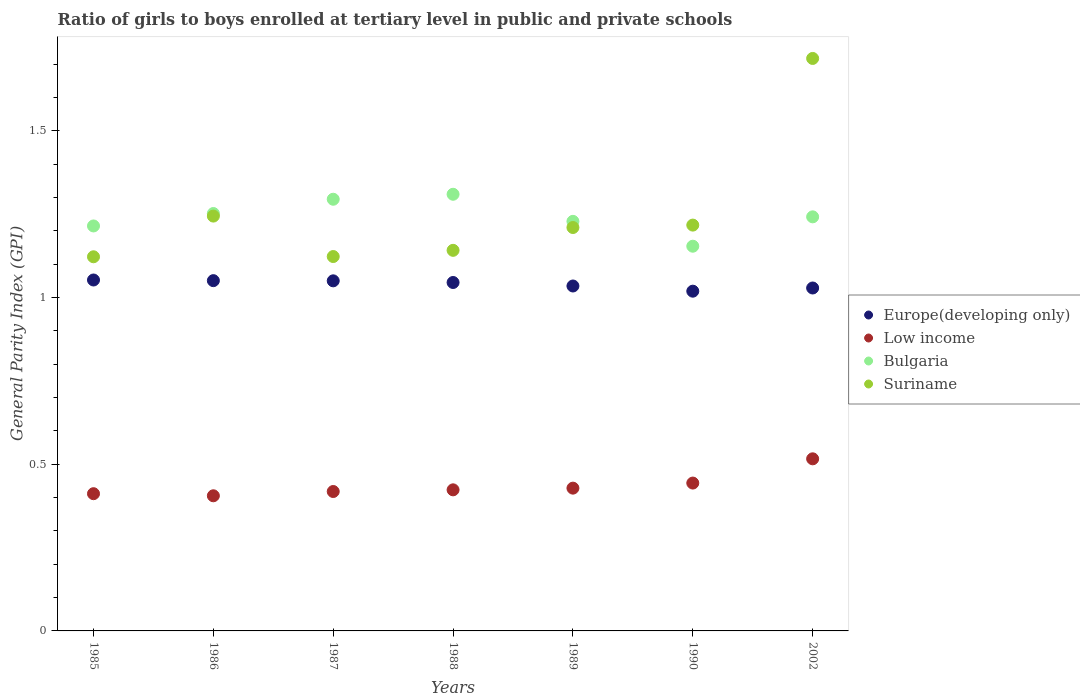Is the number of dotlines equal to the number of legend labels?
Offer a terse response. Yes. What is the general parity index in Europe(developing only) in 1985?
Your answer should be compact. 1.05. Across all years, what is the maximum general parity index in Suriname?
Your response must be concise. 1.72. Across all years, what is the minimum general parity index in Suriname?
Provide a succinct answer. 1.12. In which year was the general parity index in Bulgaria maximum?
Make the answer very short. 1988. What is the total general parity index in Low income in the graph?
Make the answer very short. 3.05. What is the difference between the general parity index in Bulgaria in 1985 and that in 1986?
Keep it short and to the point. -0.04. What is the difference between the general parity index in Bulgaria in 1988 and the general parity index in Europe(developing only) in 1987?
Offer a very short reply. 0.26. What is the average general parity index in Bulgaria per year?
Provide a short and direct response. 1.24. In the year 1990, what is the difference between the general parity index in Low income and general parity index in Suriname?
Keep it short and to the point. -0.77. What is the ratio of the general parity index in Suriname in 1985 to that in 1990?
Give a very brief answer. 0.92. Is the difference between the general parity index in Low income in 1987 and 1988 greater than the difference between the general parity index in Suriname in 1987 and 1988?
Offer a terse response. Yes. What is the difference between the highest and the second highest general parity index in Low income?
Make the answer very short. 0.07. What is the difference between the highest and the lowest general parity index in Low income?
Ensure brevity in your answer.  0.11. In how many years, is the general parity index in Suriname greater than the average general parity index in Suriname taken over all years?
Offer a very short reply. 1. Is it the case that in every year, the sum of the general parity index in Suriname and general parity index in Low income  is greater than the general parity index in Bulgaria?
Provide a succinct answer. Yes. Is the general parity index in Europe(developing only) strictly greater than the general parity index in Suriname over the years?
Make the answer very short. No. Is the general parity index in Europe(developing only) strictly less than the general parity index in Bulgaria over the years?
Your response must be concise. Yes. How many dotlines are there?
Provide a succinct answer. 4. How many years are there in the graph?
Provide a short and direct response. 7. What is the difference between two consecutive major ticks on the Y-axis?
Your answer should be compact. 0.5. Where does the legend appear in the graph?
Your answer should be compact. Center right. How are the legend labels stacked?
Make the answer very short. Vertical. What is the title of the graph?
Offer a terse response. Ratio of girls to boys enrolled at tertiary level in public and private schools. What is the label or title of the Y-axis?
Offer a very short reply. General Parity Index (GPI). What is the General Parity Index (GPI) of Europe(developing only) in 1985?
Provide a short and direct response. 1.05. What is the General Parity Index (GPI) of Low income in 1985?
Make the answer very short. 0.41. What is the General Parity Index (GPI) of Bulgaria in 1985?
Your response must be concise. 1.21. What is the General Parity Index (GPI) in Suriname in 1985?
Provide a succinct answer. 1.12. What is the General Parity Index (GPI) in Europe(developing only) in 1986?
Keep it short and to the point. 1.05. What is the General Parity Index (GPI) in Low income in 1986?
Give a very brief answer. 0.41. What is the General Parity Index (GPI) in Bulgaria in 1986?
Your answer should be compact. 1.25. What is the General Parity Index (GPI) of Suriname in 1986?
Keep it short and to the point. 1.24. What is the General Parity Index (GPI) of Europe(developing only) in 1987?
Your answer should be very brief. 1.05. What is the General Parity Index (GPI) of Low income in 1987?
Your answer should be compact. 0.42. What is the General Parity Index (GPI) of Bulgaria in 1987?
Offer a terse response. 1.29. What is the General Parity Index (GPI) in Suriname in 1987?
Offer a very short reply. 1.12. What is the General Parity Index (GPI) of Europe(developing only) in 1988?
Give a very brief answer. 1.05. What is the General Parity Index (GPI) in Low income in 1988?
Provide a succinct answer. 0.42. What is the General Parity Index (GPI) in Bulgaria in 1988?
Offer a very short reply. 1.31. What is the General Parity Index (GPI) of Suriname in 1988?
Ensure brevity in your answer.  1.14. What is the General Parity Index (GPI) of Europe(developing only) in 1989?
Your answer should be very brief. 1.03. What is the General Parity Index (GPI) of Low income in 1989?
Make the answer very short. 0.43. What is the General Parity Index (GPI) in Bulgaria in 1989?
Make the answer very short. 1.23. What is the General Parity Index (GPI) in Suriname in 1989?
Provide a short and direct response. 1.21. What is the General Parity Index (GPI) of Europe(developing only) in 1990?
Your response must be concise. 1.02. What is the General Parity Index (GPI) in Low income in 1990?
Provide a short and direct response. 0.44. What is the General Parity Index (GPI) of Bulgaria in 1990?
Your response must be concise. 1.15. What is the General Parity Index (GPI) in Suriname in 1990?
Your response must be concise. 1.22. What is the General Parity Index (GPI) of Europe(developing only) in 2002?
Offer a very short reply. 1.03. What is the General Parity Index (GPI) in Low income in 2002?
Provide a succinct answer. 0.52. What is the General Parity Index (GPI) in Bulgaria in 2002?
Provide a short and direct response. 1.24. What is the General Parity Index (GPI) in Suriname in 2002?
Your response must be concise. 1.72. Across all years, what is the maximum General Parity Index (GPI) in Europe(developing only)?
Offer a very short reply. 1.05. Across all years, what is the maximum General Parity Index (GPI) of Low income?
Offer a terse response. 0.52. Across all years, what is the maximum General Parity Index (GPI) in Bulgaria?
Your answer should be very brief. 1.31. Across all years, what is the maximum General Parity Index (GPI) in Suriname?
Ensure brevity in your answer.  1.72. Across all years, what is the minimum General Parity Index (GPI) in Europe(developing only)?
Provide a short and direct response. 1.02. Across all years, what is the minimum General Parity Index (GPI) in Low income?
Your response must be concise. 0.41. Across all years, what is the minimum General Parity Index (GPI) of Bulgaria?
Offer a terse response. 1.15. Across all years, what is the minimum General Parity Index (GPI) in Suriname?
Provide a short and direct response. 1.12. What is the total General Parity Index (GPI) in Europe(developing only) in the graph?
Make the answer very short. 7.28. What is the total General Parity Index (GPI) in Low income in the graph?
Keep it short and to the point. 3.05. What is the total General Parity Index (GPI) of Bulgaria in the graph?
Give a very brief answer. 8.7. What is the total General Parity Index (GPI) in Suriname in the graph?
Offer a very short reply. 8.78. What is the difference between the General Parity Index (GPI) of Europe(developing only) in 1985 and that in 1986?
Your response must be concise. 0. What is the difference between the General Parity Index (GPI) of Low income in 1985 and that in 1986?
Ensure brevity in your answer.  0.01. What is the difference between the General Parity Index (GPI) in Bulgaria in 1985 and that in 1986?
Offer a very short reply. -0.04. What is the difference between the General Parity Index (GPI) of Suriname in 1985 and that in 1986?
Give a very brief answer. -0.12. What is the difference between the General Parity Index (GPI) in Europe(developing only) in 1985 and that in 1987?
Offer a terse response. 0. What is the difference between the General Parity Index (GPI) in Low income in 1985 and that in 1987?
Offer a very short reply. -0.01. What is the difference between the General Parity Index (GPI) of Bulgaria in 1985 and that in 1987?
Provide a short and direct response. -0.08. What is the difference between the General Parity Index (GPI) in Suriname in 1985 and that in 1987?
Offer a very short reply. -0. What is the difference between the General Parity Index (GPI) of Europe(developing only) in 1985 and that in 1988?
Provide a succinct answer. 0.01. What is the difference between the General Parity Index (GPI) of Low income in 1985 and that in 1988?
Ensure brevity in your answer.  -0.01. What is the difference between the General Parity Index (GPI) of Bulgaria in 1985 and that in 1988?
Give a very brief answer. -0.1. What is the difference between the General Parity Index (GPI) in Suriname in 1985 and that in 1988?
Offer a very short reply. -0.02. What is the difference between the General Parity Index (GPI) in Europe(developing only) in 1985 and that in 1989?
Your answer should be very brief. 0.02. What is the difference between the General Parity Index (GPI) of Low income in 1985 and that in 1989?
Provide a short and direct response. -0.02. What is the difference between the General Parity Index (GPI) in Bulgaria in 1985 and that in 1989?
Your response must be concise. -0.01. What is the difference between the General Parity Index (GPI) of Suriname in 1985 and that in 1989?
Provide a short and direct response. -0.09. What is the difference between the General Parity Index (GPI) in Europe(developing only) in 1985 and that in 1990?
Ensure brevity in your answer.  0.03. What is the difference between the General Parity Index (GPI) in Low income in 1985 and that in 1990?
Your answer should be very brief. -0.03. What is the difference between the General Parity Index (GPI) of Bulgaria in 1985 and that in 1990?
Provide a succinct answer. 0.06. What is the difference between the General Parity Index (GPI) of Suriname in 1985 and that in 1990?
Give a very brief answer. -0.1. What is the difference between the General Parity Index (GPI) of Europe(developing only) in 1985 and that in 2002?
Provide a succinct answer. 0.02. What is the difference between the General Parity Index (GPI) in Low income in 1985 and that in 2002?
Keep it short and to the point. -0.1. What is the difference between the General Parity Index (GPI) of Bulgaria in 1985 and that in 2002?
Your answer should be very brief. -0.03. What is the difference between the General Parity Index (GPI) in Suriname in 1985 and that in 2002?
Your response must be concise. -0.59. What is the difference between the General Parity Index (GPI) of Europe(developing only) in 1986 and that in 1987?
Make the answer very short. 0. What is the difference between the General Parity Index (GPI) of Low income in 1986 and that in 1987?
Your answer should be very brief. -0.01. What is the difference between the General Parity Index (GPI) in Bulgaria in 1986 and that in 1987?
Keep it short and to the point. -0.04. What is the difference between the General Parity Index (GPI) in Suriname in 1986 and that in 1987?
Keep it short and to the point. 0.12. What is the difference between the General Parity Index (GPI) in Europe(developing only) in 1986 and that in 1988?
Give a very brief answer. 0.01. What is the difference between the General Parity Index (GPI) in Low income in 1986 and that in 1988?
Offer a very short reply. -0.02. What is the difference between the General Parity Index (GPI) in Bulgaria in 1986 and that in 1988?
Keep it short and to the point. -0.06. What is the difference between the General Parity Index (GPI) of Suriname in 1986 and that in 1988?
Provide a succinct answer. 0.1. What is the difference between the General Parity Index (GPI) of Europe(developing only) in 1986 and that in 1989?
Your answer should be very brief. 0.02. What is the difference between the General Parity Index (GPI) in Low income in 1986 and that in 1989?
Your answer should be very brief. -0.02. What is the difference between the General Parity Index (GPI) of Bulgaria in 1986 and that in 1989?
Ensure brevity in your answer.  0.02. What is the difference between the General Parity Index (GPI) of Suriname in 1986 and that in 1989?
Offer a terse response. 0.03. What is the difference between the General Parity Index (GPI) of Europe(developing only) in 1986 and that in 1990?
Your answer should be compact. 0.03. What is the difference between the General Parity Index (GPI) in Low income in 1986 and that in 1990?
Provide a succinct answer. -0.04. What is the difference between the General Parity Index (GPI) in Bulgaria in 1986 and that in 1990?
Your answer should be compact. 0.1. What is the difference between the General Parity Index (GPI) in Suriname in 1986 and that in 1990?
Give a very brief answer. 0.03. What is the difference between the General Parity Index (GPI) of Europe(developing only) in 1986 and that in 2002?
Your answer should be compact. 0.02. What is the difference between the General Parity Index (GPI) of Low income in 1986 and that in 2002?
Offer a very short reply. -0.11. What is the difference between the General Parity Index (GPI) in Bulgaria in 1986 and that in 2002?
Make the answer very short. 0.01. What is the difference between the General Parity Index (GPI) in Suriname in 1986 and that in 2002?
Offer a very short reply. -0.47. What is the difference between the General Parity Index (GPI) of Europe(developing only) in 1987 and that in 1988?
Make the answer very short. 0.01. What is the difference between the General Parity Index (GPI) of Low income in 1987 and that in 1988?
Offer a very short reply. -0.01. What is the difference between the General Parity Index (GPI) in Bulgaria in 1987 and that in 1988?
Provide a short and direct response. -0.01. What is the difference between the General Parity Index (GPI) in Suriname in 1987 and that in 1988?
Offer a very short reply. -0.02. What is the difference between the General Parity Index (GPI) in Europe(developing only) in 1987 and that in 1989?
Offer a terse response. 0.02. What is the difference between the General Parity Index (GPI) in Low income in 1987 and that in 1989?
Keep it short and to the point. -0.01. What is the difference between the General Parity Index (GPI) of Bulgaria in 1987 and that in 1989?
Give a very brief answer. 0.07. What is the difference between the General Parity Index (GPI) in Suriname in 1987 and that in 1989?
Keep it short and to the point. -0.09. What is the difference between the General Parity Index (GPI) in Europe(developing only) in 1987 and that in 1990?
Offer a terse response. 0.03. What is the difference between the General Parity Index (GPI) in Low income in 1987 and that in 1990?
Make the answer very short. -0.03. What is the difference between the General Parity Index (GPI) of Bulgaria in 1987 and that in 1990?
Make the answer very short. 0.14. What is the difference between the General Parity Index (GPI) of Suriname in 1987 and that in 1990?
Provide a succinct answer. -0.09. What is the difference between the General Parity Index (GPI) in Europe(developing only) in 1987 and that in 2002?
Provide a short and direct response. 0.02. What is the difference between the General Parity Index (GPI) of Low income in 1987 and that in 2002?
Give a very brief answer. -0.1. What is the difference between the General Parity Index (GPI) of Bulgaria in 1987 and that in 2002?
Ensure brevity in your answer.  0.05. What is the difference between the General Parity Index (GPI) in Suriname in 1987 and that in 2002?
Your response must be concise. -0.59. What is the difference between the General Parity Index (GPI) in Europe(developing only) in 1988 and that in 1989?
Make the answer very short. 0.01. What is the difference between the General Parity Index (GPI) in Low income in 1988 and that in 1989?
Give a very brief answer. -0.01. What is the difference between the General Parity Index (GPI) of Bulgaria in 1988 and that in 1989?
Ensure brevity in your answer.  0.08. What is the difference between the General Parity Index (GPI) of Suriname in 1988 and that in 1989?
Offer a very short reply. -0.07. What is the difference between the General Parity Index (GPI) of Europe(developing only) in 1988 and that in 1990?
Offer a terse response. 0.03. What is the difference between the General Parity Index (GPI) of Low income in 1988 and that in 1990?
Provide a short and direct response. -0.02. What is the difference between the General Parity Index (GPI) in Bulgaria in 1988 and that in 1990?
Provide a short and direct response. 0.16. What is the difference between the General Parity Index (GPI) of Suriname in 1988 and that in 1990?
Offer a terse response. -0.08. What is the difference between the General Parity Index (GPI) of Europe(developing only) in 1988 and that in 2002?
Your answer should be very brief. 0.02. What is the difference between the General Parity Index (GPI) in Low income in 1988 and that in 2002?
Your answer should be compact. -0.09. What is the difference between the General Parity Index (GPI) in Bulgaria in 1988 and that in 2002?
Provide a short and direct response. 0.07. What is the difference between the General Parity Index (GPI) of Suriname in 1988 and that in 2002?
Keep it short and to the point. -0.58. What is the difference between the General Parity Index (GPI) of Europe(developing only) in 1989 and that in 1990?
Ensure brevity in your answer.  0.02. What is the difference between the General Parity Index (GPI) in Low income in 1989 and that in 1990?
Ensure brevity in your answer.  -0.02. What is the difference between the General Parity Index (GPI) of Bulgaria in 1989 and that in 1990?
Keep it short and to the point. 0.07. What is the difference between the General Parity Index (GPI) in Suriname in 1989 and that in 1990?
Offer a very short reply. -0.01. What is the difference between the General Parity Index (GPI) of Europe(developing only) in 1989 and that in 2002?
Your response must be concise. 0.01. What is the difference between the General Parity Index (GPI) of Low income in 1989 and that in 2002?
Provide a succinct answer. -0.09. What is the difference between the General Parity Index (GPI) in Bulgaria in 1989 and that in 2002?
Keep it short and to the point. -0.01. What is the difference between the General Parity Index (GPI) of Suriname in 1989 and that in 2002?
Keep it short and to the point. -0.51. What is the difference between the General Parity Index (GPI) of Europe(developing only) in 1990 and that in 2002?
Offer a terse response. -0.01. What is the difference between the General Parity Index (GPI) of Low income in 1990 and that in 2002?
Make the answer very short. -0.07. What is the difference between the General Parity Index (GPI) in Bulgaria in 1990 and that in 2002?
Your answer should be very brief. -0.09. What is the difference between the General Parity Index (GPI) in Suriname in 1990 and that in 2002?
Provide a short and direct response. -0.5. What is the difference between the General Parity Index (GPI) in Europe(developing only) in 1985 and the General Parity Index (GPI) in Low income in 1986?
Make the answer very short. 0.65. What is the difference between the General Parity Index (GPI) of Europe(developing only) in 1985 and the General Parity Index (GPI) of Bulgaria in 1986?
Offer a very short reply. -0.2. What is the difference between the General Parity Index (GPI) of Europe(developing only) in 1985 and the General Parity Index (GPI) of Suriname in 1986?
Give a very brief answer. -0.19. What is the difference between the General Parity Index (GPI) of Low income in 1985 and the General Parity Index (GPI) of Bulgaria in 1986?
Give a very brief answer. -0.84. What is the difference between the General Parity Index (GPI) of Low income in 1985 and the General Parity Index (GPI) of Suriname in 1986?
Your answer should be compact. -0.83. What is the difference between the General Parity Index (GPI) in Bulgaria in 1985 and the General Parity Index (GPI) in Suriname in 1986?
Your response must be concise. -0.03. What is the difference between the General Parity Index (GPI) of Europe(developing only) in 1985 and the General Parity Index (GPI) of Low income in 1987?
Make the answer very short. 0.63. What is the difference between the General Parity Index (GPI) of Europe(developing only) in 1985 and the General Parity Index (GPI) of Bulgaria in 1987?
Your answer should be compact. -0.24. What is the difference between the General Parity Index (GPI) of Europe(developing only) in 1985 and the General Parity Index (GPI) of Suriname in 1987?
Give a very brief answer. -0.07. What is the difference between the General Parity Index (GPI) in Low income in 1985 and the General Parity Index (GPI) in Bulgaria in 1987?
Offer a terse response. -0.88. What is the difference between the General Parity Index (GPI) in Low income in 1985 and the General Parity Index (GPI) in Suriname in 1987?
Make the answer very short. -0.71. What is the difference between the General Parity Index (GPI) of Bulgaria in 1985 and the General Parity Index (GPI) of Suriname in 1987?
Your answer should be compact. 0.09. What is the difference between the General Parity Index (GPI) of Europe(developing only) in 1985 and the General Parity Index (GPI) of Low income in 1988?
Your response must be concise. 0.63. What is the difference between the General Parity Index (GPI) in Europe(developing only) in 1985 and the General Parity Index (GPI) in Bulgaria in 1988?
Your answer should be very brief. -0.26. What is the difference between the General Parity Index (GPI) of Europe(developing only) in 1985 and the General Parity Index (GPI) of Suriname in 1988?
Your answer should be compact. -0.09. What is the difference between the General Parity Index (GPI) in Low income in 1985 and the General Parity Index (GPI) in Bulgaria in 1988?
Provide a succinct answer. -0.9. What is the difference between the General Parity Index (GPI) in Low income in 1985 and the General Parity Index (GPI) in Suriname in 1988?
Offer a very short reply. -0.73. What is the difference between the General Parity Index (GPI) in Bulgaria in 1985 and the General Parity Index (GPI) in Suriname in 1988?
Make the answer very short. 0.07. What is the difference between the General Parity Index (GPI) in Europe(developing only) in 1985 and the General Parity Index (GPI) in Low income in 1989?
Offer a terse response. 0.62. What is the difference between the General Parity Index (GPI) of Europe(developing only) in 1985 and the General Parity Index (GPI) of Bulgaria in 1989?
Keep it short and to the point. -0.18. What is the difference between the General Parity Index (GPI) in Europe(developing only) in 1985 and the General Parity Index (GPI) in Suriname in 1989?
Ensure brevity in your answer.  -0.16. What is the difference between the General Parity Index (GPI) of Low income in 1985 and the General Parity Index (GPI) of Bulgaria in 1989?
Offer a very short reply. -0.82. What is the difference between the General Parity Index (GPI) of Low income in 1985 and the General Parity Index (GPI) of Suriname in 1989?
Offer a terse response. -0.8. What is the difference between the General Parity Index (GPI) of Bulgaria in 1985 and the General Parity Index (GPI) of Suriname in 1989?
Keep it short and to the point. 0. What is the difference between the General Parity Index (GPI) in Europe(developing only) in 1985 and the General Parity Index (GPI) in Low income in 1990?
Your answer should be very brief. 0.61. What is the difference between the General Parity Index (GPI) of Europe(developing only) in 1985 and the General Parity Index (GPI) of Bulgaria in 1990?
Ensure brevity in your answer.  -0.1. What is the difference between the General Parity Index (GPI) in Europe(developing only) in 1985 and the General Parity Index (GPI) in Suriname in 1990?
Give a very brief answer. -0.16. What is the difference between the General Parity Index (GPI) in Low income in 1985 and the General Parity Index (GPI) in Bulgaria in 1990?
Make the answer very short. -0.74. What is the difference between the General Parity Index (GPI) of Low income in 1985 and the General Parity Index (GPI) of Suriname in 1990?
Your answer should be compact. -0.81. What is the difference between the General Parity Index (GPI) in Bulgaria in 1985 and the General Parity Index (GPI) in Suriname in 1990?
Provide a succinct answer. -0. What is the difference between the General Parity Index (GPI) of Europe(developing only) in 1985 and the General Parity Index (GPI) of Low income in 2002?
Ensure brevity in your answer.  0.54. What is the difference between the General Parity Index (GPI) in Europe(developing only) in 1985 and the General Parity Index (GPI) in Bulgaria in 2002?
Provide a succinct answer. -0.19. What is the difference between the General Parity Index (GPI) in Europe(developing only) in 1985 and the General Parity Index (GPI) in Suriname in 2002?
Keep it short and to the point. -0.66. What is the difference between the General Parity Index (GPI) of Low income in 1985 and the General Parity Index (GPI) of Bulgaria in 2002?
Provide a short and direct response. -0.83. What is the difference between the General Parity Index (GPI) in Low income in 1985 and the General Parity Index (GPI) in Suriname in 2002?
Offer a very short reply. -1.31. What is the difference between the General Parity Index (GPI) of Bulgaria in 1985 and the General Parity Index (GPI) of Suriname in 2002?
Give a very brief answer. -0.5. What is the difference between the General Parity Index (GPI) in Europe(developing only) in 1986 and the General Parity Index (GPI) in Low income in 1987?
Give a very brief answer. 0.63. What is the difference between the General Parity Index (GPI) in Europe(developing only) in 1986 and the General Parity Index (GPI) in Bulgaria in 1987?
Your answer should be compact. -0.24. What is the difference between the General Parity Index (GPI) in Europe(developing only) in 1986 and the General Parity Index (GPI) in Suriname in 1987?
Your answer should be very brief. -0.07. What is the difference between the General Parity Index (GPI) in Low income in 1986 and the General Parity Index (GPI) in Bulgaria in 1987?
Keep it short and to the point. -0.89. What is the difference between the General Parity Index (GPI) of Low income in 1986 and the General Parity Index (GPI) of Suriname in 1987?
Offer a terse response. -0.72. What is the difference between the General Parity Index (GPI) of Bulgaria in 1986 and the General Parity Index (GPI) of Suriname in 1987?
Offer a very short reply. 0.13. What is the difference between the General Parity Index (GPI) of Europe(developing only) in 1986 and the General Parity Index (GPI) of Low income in 1988?
Your response must be concise. 0.63. What is the difference between the General Parity Index (GPI) in Europe(developing only) in 1986 and the General Parity Index (GPI) in Bulgaria in 1988?
Offer a very short reply. -0.26. What is the difference between the General Parity Index (GPI) in Europe(developing only) in 1986 and the General Parity Index (GPI) in Suriname in 1988?
Provide a short and direct response. -0.09. What is the difference between the General Parity Index (GPI) of Low income in 1986 and the General Parity Index (GPI) of Bulgaria in 1988?
Offer a very short reply. -0.9. What is the difference between the General Parity Index (GPI) in Low income in 1986 and the General Parity Index (GPI) in Suriname in 1988?
Provide a succinct answer. -0.74. What is the difference between the General Parity Index (GPI) of Bulgaria in 1986 and the General Parity Index (GPI) of Suriname in 1988?
Offer a very short reply. 0.11. What is the difference between the General Parity Index (GPI) of Europe(developing only) in 1986 and the General Parity Index (GPI) of Low income in 1989?
Ensure brevity in your answer.  0.62. What is the difference between the General Parity Index (GPI) in Europe(developing only) in 1986 and the General Parity Index (GPI) in Bulgaria in 1989?
Make the answer very short. -0.18. What is the difference between the General Parity Index (GPI) of Europe(developing only) in 1986 and the General Parity Index (GPI) of Suriname in 1989?
Keep it short and to the point. -0.16. What is the difference between the General Parity Index (GPI) of Low income in 1986 and the General Parity Index (GPI) of Bulgaria in 1989?
Provide a succinct answer. -0.82. What is the difference between the General Parity Index (GPI) of Low income in 1986 and the General Parity Index (GPI) of Suriname in 1989?
Make the answer very short. -0.8. What is the difference between the General Parity Index (GPI) in Bulgaria in 1986 and the General Parity Index (GPI) in Suriname in 1989?
Your answer should be compact. 0.04. What is the difference between the General Parity Index (GPI) in Europe(developing only) in 1986 and the General Parity Index (GPI) in Low income in 1990?
Keep it short and to the point. 0.61. What is the difference between the General Parity Index (GPI) of Europe(developing only) in 1986 and the General Parity Index (GPI) of Bulgaria in 1990?
Provide a succinct answer. -0.1. What is the difference between the General Parity Index (GPI) in Europe(developing only) in 1986 and the General Parity Index (GPI) in Suriname in 1990?
Give a very brief answer. -0.17. What is the difference between the General Parity Index (GPI) in Low income in 1986 and the General Parity Index (GPI) in Bulgaria in 1990?
Your answer should be compact. -0.75. What is the difference between the General Parity Index (GPI) of Low income in 1986 and the General Parity Index (GPI) of Suriname in 1990?
Give a very brief answer. -0.81. What is the difference between the General Parity Index (GPI) in Bulgaria in 1986 and the General Parity Index (GPI) in Suriname in 1990?
Keep it short and to the point. 0.03. What is the difference between the General Parity Index (GPI) of Europe(developing only) in 1986 and the General Parity Index (GPI) of Low income in 2002?
Your answer should be compact. 0.53. What is the difference between the General Parity Index (GPI) of Europe(developing only) in 1986 and the General Parity Index (GPI) of Bulgaria in 2002?
Provide a succinct answer. -0.19. What is the difference between the General Parity Index (GPI) of Europe(developing only) in 1986 and the General Parity Index (GPI) of Suriname in 2002?
Offer a terse response. -0.67. What is the difference between the General Parity Index (GPI) of Low income in 1986 and the General Parity Index (GPI) of Bulgaria in 2002?
Give a very brief answer. -0.84. What is the difference between the General Parity Index (GPI) in Low income in 1986 and the General Parity Index (GPI) in Suriname in 2002?
Make the answer very short. -1.31. What is the difference between the General Parity Index (GPI) of Bulgaria in 1986 and the General Parity Index (GPI) of Suriname in 2002?
Provide a short and direct response. -0.47. What is the difference between the General Parity Index (GPI) of Europe(developing only) in 1987 and the General Parity Index (GPI) of Low income in 1988?
Your answer should be compact. 0.63. What is the difference between the General Parity Index (GPI) in Europe(developing only) in 1987 and the General Parity Index (GPI) in Bulgaria in 1988?
Give a very brief answer. -0.26. What is the difference between the General Parity Index (GPI) of Europe(developing only) in 1987 and the General Parity Index (GPI) of Suriname in 1988?
Provide a short and direct response. -0.09. What is the difference between the General Parity Index (GPI) in Low income in 1987 and the General Parity Index (GPI) in Bulgaria in 1988?
Your response must be concise. -0.89. What is the difference between the General Parity Index (GPI) in Low income in 1987 and the General Parity Index (GPI) in Suriname in 1988?
Offer a very short reply. -0.72. What is the difference between the General Parity Index (GPI) in Bulgaria in 1987 and the General Parity Index (GPI) in Suriname in 1988?
Your response must be concise. 0.15. What is the difference between the General Parity Index (GPI) of Europe(developing only) in 1987 and the General Parity Index (GPI) of Low income in 1989?
Offer a terse response. 0.62. What is the difference between the General Parity Index (GPI) of Europe(developing only) in 1987 and the General Parity Index (GPI) of Bulgaria in 1989?
Offer a terse response. -0.18. What is the difference between the General Parity Index (GPI) of Europe(developing only) in 1987 and the General Parity Index (GPI) of Suriname in 1989?
Offer a very short reply. -0.16. What is the difference between the General Parity Index (GPI) in Low income in 1987 and the General Parity Index (GPI) in Bulgaria in 1989?
Give a very brief answer. -0.81. What is the difference between the General Parity Index (GPI) of Low income in 1987 and the General Parity Index (GPI) of Suriname in 1989?
Give a very brief answer. -0.79. What is the difference between the General Parity Index (GPI) of Bulgaria in 1987 and the General Parity Index (GPI) of Suriname in 1989?
Your answer should be compact. 0.08. What is the difference between the General Parity Index (GPI) of Europe(developing only) in 1987 and the General Parity Index (GPI) of Low income in 1990?
Make the answer very short. 0.61. What is the difference between the General Parity Index (GPI) of Europe(developing only) in 1987 and the General Parity Index (GPI) of Bulgaria in 1990?
Your response must be concise. -0.1. What is the difference between the General Parity Index (GPI) in Europe(developing only) in 1987 and the General Parity Index (GPI) in Suriname in 1990?
Provide a succinct answer. -0.17. What is the difference between the General Parity Index (GPI) of Low income in 1987 and the General Parity Index (GPI) of Bulgaria in 1990?
Offer a terse response. -0.74. What is the difference between the General Parity Index (GPI) of Low income in 1987 and the General Parity Index (GPI) of Suriname in 1990?
Your response must be concise. -0.8. What is the difference between the General Parity Index (GPI) in Bulgaria in 1987 and the General Parity Index (GPI) in Suriname in 1990?
Give a very brief answer. 0.08. What is the difference between the General Parity Index (GPI) in Europe(developing only) in 1987 and the General Parity Index (GPI) in Low income in 2002?
Offer a terse response. 0.53. What is the difference between the General Parity Index (GPI) of Europe(developing only) in 1987 and the General Parity Index (GPI) of Bulgaria in 2002?
Make the answer very short. -0.19. What is the difference between the General Parity Index (GPI) of Europe(developing only) in 1987 and the General Parity Index (GPI) of Suriname in 2002?
Your answer should be compact. -0.67. What is the difference between the General Parity Index (GPI) in Low income in 1987 and the General Parity Index (GPI) in Bulgaria in 2002?
Ensure brevity in your answer.  -0.82. What is the difference between the General Parity Index (GPI) of Low income in 1987 and the General Parity Index (GPI) of Suriname in 2002?
Give a very brief answer. -1.3. What is the difference between the General Parity Index (GPI) of Bulgaria in 1987 and the General Parity Index (GPI) of Suriname in 2002?
Make the answer very short. -0.42. What is the difference between the General Parity Index (GPI) of Europe(developing only) in 1988 and the General Parity Index (GPI) of Low income in 1989?
Offer a very short reply. 0.62. What is the difference between the General Parity Index (GPI) of Europe(developing only) in 1988 and the General Parity Index (GPI) of Bulgaria in 1989?
Ensure brevity in your answer.  -0.18. What is the difference between the General Parity Index (GPI) in Europe(developing only) in 1988 and the General Parity Index (GPI) in Suriname in 1989?
Your answer should be very brief. -0.16. What is the difference between the General Parity Index (GPI) in Low income in 1988 and the General Parity Index (GPI) in Bulgaria in 1989?
Your answer should be compact. -0.81. What is the difference between the General Parity Index (GPI) in Low income in 1988 and the General Parity Index (GPI) in Suriname in 1989?
Keep it short and to the point. -0.79. What is the difference between the General Parity Index (GPI) in Bulgaria in 1988 and the General Parity Index (GPI) in Suriname in 1989?
Make the answer very short. 0.1. What is the difference between the General Parity Index (GPI) in Europe(developing only) in 1988 and the General Parity Index (GPI) in Low income in 1990?
Keep it short and to the point. 0.6. What is the difference between the General Parity Index (GPI) of Europe(developing only) in 1988 and the General Parity Index (GPI) of Bulgaria in 1990?
Keep it short and to the point. -0.11. What is the difference between the General Parity Index (GPI) in Europe(developing only) in 1988 and the General Parity Index (GPI) in Suriname in 1990?
Make the answer very short. -0.17. What is the difference between the General Parity Index (GPI) in Low income in 1988 and the General Parity Index (GPI) in Bulgaria in 1990?
Offer a terse response. -0.73. What is the difference between the General Parity Index (GPI) of Low income in 1988 and the General Parity Index (GPI) of Suriname in 1990?
Provide a short and direct response. -0.79. What is the difference between the General Parity Index (GPI) in Bulgaria in 1988 and the General Parity Index (GPI) in Suriname in 1990?
Keep it short and to the point. 0.09. What is the difference between the General Parity Index (GPI) of Europe(developing only) in 1988 and the General Parity Index (GPI) of Low income in 2002?
Provide a short and direct response. 0.53. What is the difference between the General Parity Index (GPI) of Europe(developing only) in 1988 and the General Parity Index (GPI) of Bulgaria in 2002?
Your response must be concise. -0.2. What is the difference between the General Parity Index (GPI) of Europe(developing only) in 1988 and the General Parity Index (GPI) of Suriname in 2002?
Offer a very short reply. -0.67. What is the difference between the General Parity Index (GPI) of Low income in 1988 and the General Parity Index (GPI) of Bulgaria in 2002?
Ensure brevity in your answer.  -0.82. What is the difference between the General Parity Index (GPI) of Low income in 1988 and the General Parity Index (GPI) of Suriname in 2002?
Your answer should be compact. -1.29. What is the difference between the General Parity Index (GPI) of Bulgaria in 1988 and the General Parity Index (GPI) of Suriname in 2002?
Give a very brief answer. -0.41. What is the difference between the General Parity Index (GPI) of Europe(developing only) in 1989 and the General Parity Index (GPI) of Low income in 1990?
Ensure brevity in your answer.  0.59. What is the difference between the General Parity Index (GPI) of Europe(developing only) in 1989 and the General Parity Index (GPI) of Bulgaria in 1990?
Offer a very short reply. -0.12. What is the difference between the General Parity Index (GPI) in Europe(developing only) in 1989 and the General Parity Index (GPI) in Suriname in 1990?
Ensure brevity in your answer.  -0.18. What is the difference between the General Parity Index (GPI) in Low income in 1989 and the General Parity Index (GPI) in Bulgaria in 1990?
Offer a very short reply. -0.73. What is the difference between the General Parity Index (GPI) of Low income in 1989 and the General Parity Index (GPI) of Suriname in 1990?
Make the answer very short. -0.79. What is the difference between the General Parity Index (GPI) in Bulgaria in 1989 and the General Parity Index (GPI) in Suriname in 1990?
Provide a succinct answer. 0.01. What is the difference between the General Parity Index (GPI) in Europe(developing only) in 1989 and the General Parity Index (GPI) in Low income in 2002?
Your response must be concise. 0.52. What is the difference between the General Parity Index (GPI) of Europe(developing only) in 1989 and the General Parity Index (GPI) of Bulgaria in 2002?
Provide a succinct answer. -0.21. What is the difference between the General Parity Index (GPI) of Europe(developing only) in 1989 and the General Parity Index (GPI) of Suriname in 2002?
Ensure brevity in your answer.  -0.68. What is the difference between the General Parity Index (GPI) of Low income in 1989 and the General Parity Index (GPI) of Bulgaria in 2002?
Make the answer very short. -0.81. What is the difference between the General Parity Index (GPI) in Low income in 1989 and the General Parity Index (GPI) in Suriname in 2002?
Offer a very short reply. -1.29. What is the difference between the General Parity Index (GPI) of Bulgaria in 1989 and the General Parity Index (GPI) of Suriname in 2002?
Offer a very short reply. -0.49. What is the difference between the General Parity Index (GPI) in Europe(developing only) in 1990 and the General Parity Index (GPI) in Low income in 2002?
Your answer should be very brief. 0.5. What is the difference between the General Parity Index (GPI) in Europe(developing only) in 1990 and the General Parity Index (GPI) in Bulgaria in 2002?
Your response must be concise. -0.22. What is the difference between the General Parity Index (GPI) in Europe(developing only) in 1990 and the General Parity Index (GPI) in Suriname in 2002?
Make the answer very short. -0.7. What is the difference between the General Parity Index (GPI) of Low income in 1990 and the General Parity Index (GPI) of Bulgaria in 2002?
Offer a terse response. -0.8. What is the difference between the General Parity Index (GPI) in Low income in 1990 and the General Parity Index (GPI) in Suriname in 2002?
Ensure brevity in your answer.  -1.27. What is the difference between the General Parity Index (GPI) of Bulgaria in 1990 and the General Parity Index (GPI) of Suriname in 2002?
Keep it short and to the point. -0.56. What is the average General Parity Index (GPI) of Europe(developing only) per year?
Provide a short and direct response. 1.04. What is the average General Parity Index (GPI) of Low income per year?
Make the answer very short. 0.44. What is the average General Parity Index (GPI) in Bulgaria per year?
Make the answer very short. 1.24. What is the average General Parity Index (GPI) in Suriname per year?
Your response must be concise. 1.25. In the year 1985, what is the difference between the General Parity Index (GPI) of Europe(developing only) and General Parity Index (GPI) of Low income?
Provide a succinct answer. 0.64. In the year 1985, what is the difference between the General Parity Index (GPI) in Europe(developing only) and General Parity Index (GPI) in Bulgaria?
Your response must be concise. -0.16. In the year 1985, what is the difference between the General Parity Index (GPI) in Europe(developing only) and General Parity Index (GPI) in Suriname?
Your answer should be very brief. -0.07. In the year 1985, what is the difference between the General Parity Index (GPI) of Low income and General Parity Index (GPI) of Bulgaria?
Your answer should be very brief. -0.8. In the year 1985, what is the difference between the General Parity Index (GPI) in Low income and General Parity Index (GPI) in Suriname?
Your answer should be compact. -0.71. In the year 1985, what is the difference between the General Parity Index (GPI) of Bulgaria and General Parity Index (GPI) of Suriname?
Provide a succinct answer. 0.09. In the year 1986, what is the difference between the General Parity Index (GPI) of Europe(developing only) and General Parity Index (GPI) of Low income?
Your answer should be very brief. 0.65. In the year 1986, what is the difference between the General Parity Index (GPI) in Europe(developing only) and General Parity Index (GPI) in Bulgaria?
Ensure brevity in your answer.  -0.2. In the year 1986, what is the difference between the General Parity Index (GPI) in Europe(developing only) and General Parity Index (GPI) in Suriname?
Give a very brief answer. -0.19. In the year 1986, what is the difference between the General Parity Index (GPI) of Low income and General Parity Index (GPI) of Bulgaria?
Offer a very short reply. -0.85. In the year 1986, what is the difference between the General Parity Index (GPI) in Low income and General Parity Index (GPI) in Suriname?
Provide a short and direct response. -0.84. In the year 1986, what is the difference between the General Parity Index (GPI) of Bulgaria and General Parity Index (GPI) of Suriname?
Offer a terse response. 0.01. In the year 1987, what is the difference between the General Parity Index (GPI) in Europe(developing only) and General Parity Index (GPI) in Low income?
Ensure brevity in your answer.  0.63. In the year 1987, what is the difference between the General Parity Index (GPI) of Europe(developing only) and General Parity Index (GPI) of Bulgaria?
Your response must be concise. -0.24. In the year 1987, what is the difference between the General Parity Index (GPI) of Europe(developing only) and General Parity Index (GPI) of Suriname?
Your response must be concise. -0.07. In the year 1987, what is the difference between the General Parity Index (GPI) in Low income and General Parity Index (GPI) in Bulgaria?
Ensure brevity in your answer.  -0.88. In the year 1987, what is the difference between the General Parity Index (GPI) of Low income and General Parity Index (GPI) of Suriname?
Offer a very short reply. -0.7. In the year 1987, what is the difference between the General Parity Index (GPI) of Bulgaria and General Parity Index (GPI) of Suriname?
Your response must be concise. 0.17. In the year 1988, what is the difference between the General Parity Index (GPI) in Europe(developing only) and General Parity Index (GPI) in Low income?
Offer a very short reply. 0.62. In the year 1988, what is the difference between the General Parity Index (GPI) of Europe(developing only) and General Parity Index (GPI) of Bulgaria?
Your answer should be compact. -0.26. In the year 1988, what is the difference between the General Parity Index (GPI) in Europe(developing only) and General Parity Index (GPI) in Suriname?
Provide a succinct answer. -0.1. In the year 1988, what is the difference between the General Parity Index (GPI) in Low income and General Parity Index (GPI) in Bulgaria?
Offer a terse response. -0.89. In the year 1988, what is the difference between the General Parity Index (GPI) of Low income and General Parity Index (GPI) of Suriname?
Keep it short and to the point. -0.72. In the year 1988, what is the difference between the General Parity Index (GPI) of Bulgaria and General Parity Index (GPI) of Suriname?
Make the answer very short. 0.17. In the year 1989, what is the difference between the General Parity Index (GPI) of Europe(developing only) and General Parity Index (GPI) of Low income?
Keep it short and to the point. 0.61. In the year 1989, what is the difference between the General Parity Index (GPI) of Europe(developing only) and General Parity Index (GPI) of Bulgaria?
Keep it short and to the point. -0.19. In the year 1989, what is the difference between the General Parity Index (GPI) in Europe(developing only) and General Parity Index (GPI) in Suriname?
Your answer should be very brief. -0.18. In the year 1989, what is the difference between the General Parity Index (GPI) in Low income and General Parity Index (GPI) in Bulgaria?
Keep it short and to the point. -0.8. In the year 1989, what is the difference between the General Parity Index (GPI) of Low income and General Parity Index (GPI) of Suriname?
Offer a terse response. -0.78. In the year 1989, what is the difference between the General Parity Index (GPI) in Bulgaria and General Parity Index (GPI) in Suriname?
Offer a terse response. 0.02. In the year 1990, what is the difference between the General Parity Index (GPI) of Europe(developing only) and General Parity Index (GPI) of Low income?
Keep it short and to the point. 0.58. In the year 1990, what is the difference between the General Parity Index (GPI) in Europe(developing only) and General Parity Index (GPI) in Bulgaria?
Make the answer very short. -0.13. In the year 1990, what is the difference between the General Parity Index (GPI) in Europe(developing only) and General Parity Index (GPI) in Suriname?
Keep it short and to the point. -0.2. In the year 1990, what is the difference between the General Parity Index (GPI) in Low income and General Parity Index (GPI) in Bulgaria?
Provide a short and direct response. -0.71. In the year 1990, what is the difference between the General Parity Index (GPI) of Low income and General Parity Index (GPI) of Suriname?
Provide a short and direct response. -0.77. In the year 1990, what is the difference between the General Parity Index (GPI) of Bulgaria and General Parity Index (GPI) of Suriname?
Keep it short and to the point. -0.06. In the year 2002, what is the difference between the General Parity Index (GPI) of Europe(developing only) and General Parity Index (GPI) of Low income?
Your answer should be compact. 0.51. In the year 2002, what is the difference between the General Parity Index (GPI) in Europe(developing only) and General Parity Index (GPI) in Bulgaria?
Offer a terse response. -0.21. In the year 2002, what is the difference between the General Parity Index (GPI) of Europe(developing only) and General Parity Index (GPI) of Suriname?
Your answer should be very brief. -0.69. In the year 2002, what is the difference between the General Parity Index (GPI) of Low income and General Parity Index (GPI) of Bulgaria?
Make the answer very short. -0.73. In the year 2002, what is the difference between the General Parity Index (GPI) in Low income and General Parity Index (GPI) in Suriname?
Ensure brevity in your answer.  -1.2. In the year 2002, what is the difference between the General Parity Index (GPI) of Bulgaria and General Parity Index (GPI) of Suriname?
Make the answer very short. -0.48. What is the ratio of the General Parity Index (GPI) of Low income in 1985 to that in 1986?
Ensure brevity in your answer.  1.02. What is the ratio of the General Parity Index (GPI) in Bulgaria in 1985 to that in 1986?
Your answer should be very brief. 0.97. What is the ratio of the General Parity Index (GPI) in Suriname in 1985 to that in 1986?
Make the answer very short. 0.9. What is the ratio of the General Parity Index (GPI) in Low income in 1985 to that in 1987?
Ensure brevity in your answer.  0.98. What is the ratio of the General Parity Index (GPI) of Bulgaria in 1985 to that in 1987?
Your answer should be compact. 0.94. What is the ratio of the General Parity Index (GPI) of Suriname in 1985 to that in 1987?
Provide a short and direct response. 1. What is the ratio of the General Parity Index (GPI) in Low income in 1985 to that in 1988?
Your response must be concise. 0.97. What is the ratio of the General Parity Index (GPI) in Bulgaria in 1985 to that in 1988?
Your answer should be compact. 0.93. What is the ratio of the General Parity Index (GPI) in Suriname in 1985 to that in 1988?
Your response must be concise. 0.98. What is the ratio of the General Parity Index (GPI) in Europe(developing only) in 1985 to that in 1989?
Provide a short and direct response. 1.02. What is the ratio of the General Parity Index (GPI) of Low income in 1985 to that in 1989?
Provide a succinct answer. 0.96. What is the ratio of the General Parity Index (GPI) of Suriname in 1985 to that in 1989?
Provide a short and direct response. 0.93. What is the ratio of the General Parity Index (GPI) in Europe(developing only) in 1985 to that in 1990?
Offer a terse response. 1.03. What is the ratio of the General Parity Index (GPI) in Low income in 1985 to that in 1990?
Provide a succinct answer. 0.93. What is the ratio of the General Parity Index (GPI) of Bulgaria in 1985 to that in 1990?
Your response must be concise. 1.05. What is the ratio of the General Parity Index (GPI) of Suriname in 1985 to that in 1990?
Offer a terse response. 0.92. What is the ratio of the General Parity Index (GPI) in Europe(developing only) in 1985 to that in 2002?
Make the answer very short. 1.02. What is the ratio of the General Parity Index (GPI) of Low income in 1985 to that in 2002?
Offer a terse response. 0.8. What is the ratio of the General Parity Index (GPI) in Bulgaria in 1985 to that in 2002?
Offer a terse response. 0.98. What is the ratio of the General Parity Index (GPI) in Suriname in 1985 to that in 2002?
Keep it short and to the point. 0.65. What is the ratio of the General Parity Index (GPI) of Low income in 1986 to that in 1987?
Make the answer very short. 0.97. What is the ratio of the General Parity Index (GPI) of Bulgaria in 1986 to that in 1987?
Offer a very short reply. 0.97. What is the ratio of the General Parity Index (GPI) of Suriname in 1986 to that in 1987?
Provide a short and direct response. 1.11. What is the ratio of the General Parity Index (GPI) of Low income in 1986 to that in 1988?
Provide a succinct answer. 0.96. What is the ratio of the General Parity Index (GPI) of Bulgaria in 1986 to that in 1988?
Provide a short and direct response. 0.96. What is the ratio of the General Parity Index (GPI) of Suriname in 1986 to that in 1988?
Your answer should be compact. 1.09. What is the ratio of the General Parity Index (GPI) of Europe(developing only) in 1986 to that in 1989?
Offer a terse response. 1.02. What is the ratio of the General Parity Index (GPI) of Low income in 1986 to that in 1989?
Keep it short and to the point. 0.95. What is the ratio of the General Parity Index (GPI) of Bulgaria in 1986 to that in 1989?
Keep it short and to the point. 1.02. What is the ratio of the General Parity Index (GPI) in Suriname in 1986 to that in 1989?
Offer a terse response. 1.03. What is the ratio of the General Parity Index (GPI) of Europe(developing only) in 1986 to that in 1990?
Provide a succinct answer. 1.03. What is the ratio of the General Parity Index (GPI) in Low income in 1986 to that in 1990?
Your answer should be very brief. 0.91. What is the ratio of the General Parity Index (GPI) in Bulgaria in 1986 to that in 1990?
Ensure brevity in your answer.  1.08. What is the ratio of the General Parity Index (GPI) in Suriname in 1986 to that in 1990?
Keep it short and to the point. 1.02. What is the ratio of the General Parity Index (GPI) in Europe(developing only) in 1986 to that in 2002?
Ensure brevity in your answer.  1.02. What is the ratio of the General Parity Index (GPI) of Low income in 1986 to that in 2002?
Your answer should be compact. 0.79. What is the ratio of the General Parity Index (GPI) in Suriname in 1986 to that in 2002?
Make the answer very short. 0.72. What is the ratio of the General Parity Index (GPI) in Europe(developing only) in 1987 to that in 1988?
Keep it short and to the point. 1. What is the ratio of the General Parity Index (GPI) of Low income in 1987 to that in 1988?
Provide a succinct answer. 0.99. What is the ratio of the General Parity Index (GPI) in Bulgaria in 1987 to that in 1988?
Ensure brevity in your answer.  0.99. What is the ratio of the General Parity Index (GPI) of Suriname in 1987 to that in 1988?
Ensure brevity in your answer.  0.98. What is the ratio of the General Parity Index (GPI) in Low income in 1987 to that in 1989?
Ensure brevity in your answer.  0.98. What is the ratio of the General Parity Index (GPI) in Bulgaria in 1987 to that in 1989?
Give a very brief answer. 1.05. What is the ratio of the General Parity Index (GPI) in Suriname in 1987 to that in 1989?
Provide a succinct answer. 0.93. What is the ratio of the General Parity Index (GPI) of Europe(developing only) in 1987 to that in 1990?
Keep it short and to the point. 1.03. What is the ratio of the General Parity Index (GPI) of Low income in 1987 to that in 1990?
Provide a succinct answer. 0.94. What is the ratio of the General Parity Index (GPI) in Bulgaria in 1987 to that in 1990?
Provide a succinct answer. 1.12. What is the ratio of the General Parity Index (GPI) in Suriname in 1987 to that in 1990?
Provide a short and direct response. 0.92. What is the ratio of the General Parity Index (GPI) of Europe(developing only) in 1987 to that in 2002?
Give a very brief answer. 1.02. What is the ratio of the General Parity Index (GPI) of Low income in 1987 to that in 2002?
Offer a terse response. 0.81. What is the ratio of the General Parity Index (GPI) of Bulgaria in 1987 to that in 2002?
Give a very brief answer. 1.04. What is the ratio of the General Parity Index (GPI) in Suriname in 1987 to that in 2002?
Provide a short and direct response. 0.65. What is the ratio of the General Parity Index (GPI) of Low income in 1988 to that in 1989?
Make the answer very short. 0.99. What is the ratio of the General Parity Index (GPI) of Bulgaria in 1988 to that in 1989?
Your answer should be compact. 1.07. What is the ratio of the General Parity Index (GPI) of Suriname in 1988 to that in 1989?
Keep it short and to the point. 0.94. What is the ratio of the General Parity Index (GPI) of Europe(developing only) in 1988 to that in 1990?
Offer a very short reply. 1.03. What is the ratio of the General Parity Index (GPI) in Low income in 1988 to that in 1990?
Offer a very short reply. 0.95. What is the ratio of the General Parity Index (GPI) in Bulgaria in 1988 to that in 1990?
Your answer should be compact. 1.14. What is the ratio of the General Parity Index (GPI) in Suriname in 1988 to that in 1990?
Give a very brief answer. 0.94. What is the ratio of the General Parity Index (GPI) in Low income in 1988 to that in 2002?
Your answer should be compact. 0.82. What is the ratio of the General Parity Index (GPI) of Bulgaria in 1988 to that in 2002?
Keep it short and to the point. 1.05. What is the ratio of the General Parity Index (GPI) in Suriname in 1988 to that in 2002?
Your answer should be compact. 0.66. What is the ratio of the General Parity Index (GPI) in Europe(developing only) in 1989 to that in 1990?
Give a very brief answer. 1.02. What is the ratio of the General Parity Index (GPI) of Low income in 1989 to that in 1990?
Your answer should be very brief. 0.97. What is the ratio of the General Parity Index (GPI) of Bulgaria in 1989 to that in 1990?
Ensure brevity in your answer.  1.06. What is the ratio of the General Parity Index (GPI) of Europe(developing only) in 1989 to that in 2002?
Give a very brief answer. 1.01. What is the ratio of the General Parity Index (GPI) in Low income in 1989 to that in 2002?
Offer a very short reply. 0.83. What is the ratio of the General Parity Index (GPI) in Bulgaria in 1989 to that in 2002?
Offer a terse response. 0.99. What is the ratio of the General Parity Index (GPI) of Suriname in 1989 to that in 2002?
Offer a very short reply. 0.7. What is the ratio of the General Parity Index (GPI) in Low income in 1990 to that in 2002?
Give a very brief answer. 0.86. What is the ratio of the General Parity Index (GPI) of Bulgaria in 1990 to that in 2002?
Keep it short and to the point. 0.93. What is the ratio of the General Parity Index (GPI) of Suriname in 1990 to that in 2002?
Provide a short and direct response. 0.71. What is the difference between the highest and the second highest General Parity Index (GPI) in Europe(developing only)?
Offer a terse response. 0. What is the difference between the highest and the second highest General Parity Index (GPI) in Low income?
Make the answer very short. 0.07. What is the difference between the highest and the second highest General Parity Index (GPI) in Bulgaria?
Give a very brief answer. 0.01. What is the difference between the highest and the second highest General Parity Index (GPI) of Suriname?
Offer a very short reply. 0.47. What is the difference between the highest and the lowest General Parity Index (GPI) of Europe(developing only)?
Your response must be concise. 0.03. What is the difference between the highest and the lowest General Parity Index (GPI) of Low income?
Your answer should be very brief. 0.11. What is the difference between the highest and the lowest General Parity Index (GPI) in Bulgaria?
Provide a short and direct response. 0.16. What is the difference between the highest and the lowest General Parity Index (GPI) of Suriname?
Give a very brief answer. 0.59. 